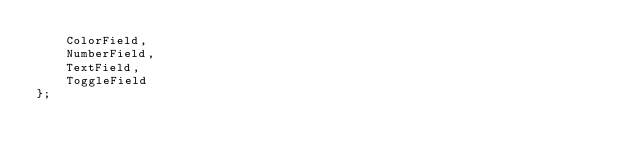<code> <loc_0><loc_0><loc_500><loc_500><_TypeScript_>    ColorField,
    NumberField,
    TextField,
    ToggleField
};
</code> 